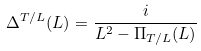Convert formula to latex. <formula><loc_0><loc_0><loc_500><loc_500>\Delta ^ { T / L } ( L ) & = \frac { i } { L ^ { 2 } - \Pi _ { T / L } ( L ) }</formula> 